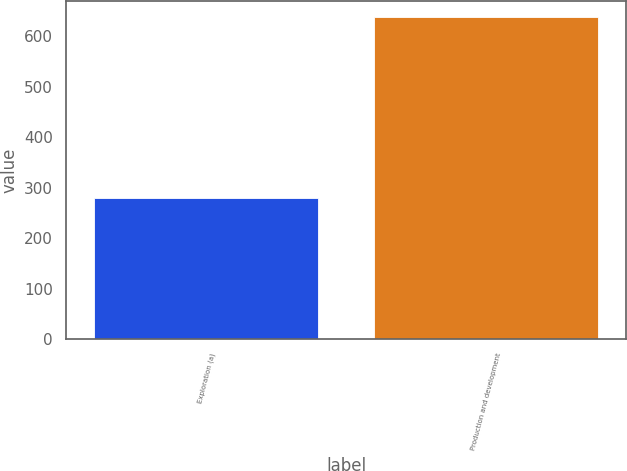Convert chart to OTSL. <chart><loc_0><loc_0><loc_500><loc_500><bar_chart><fcel>Exploration (a)<fcel>Production and development<nl><fcel>280<fcel>639<nl></chart> 